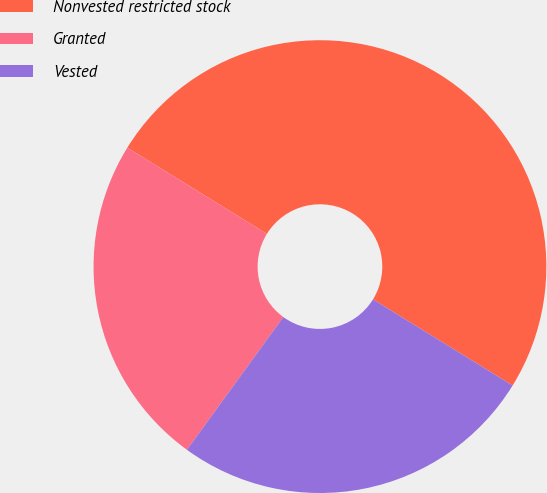<chart> <loc_0><loc_0><loc_500><loc_500><pie_chart><fcel>Nonvested restricted stock<fcel>Granted<fcel>Vested<nl><fcel>50.0%<fcel>23.81%<fcel>26.19%<nl></chart> 